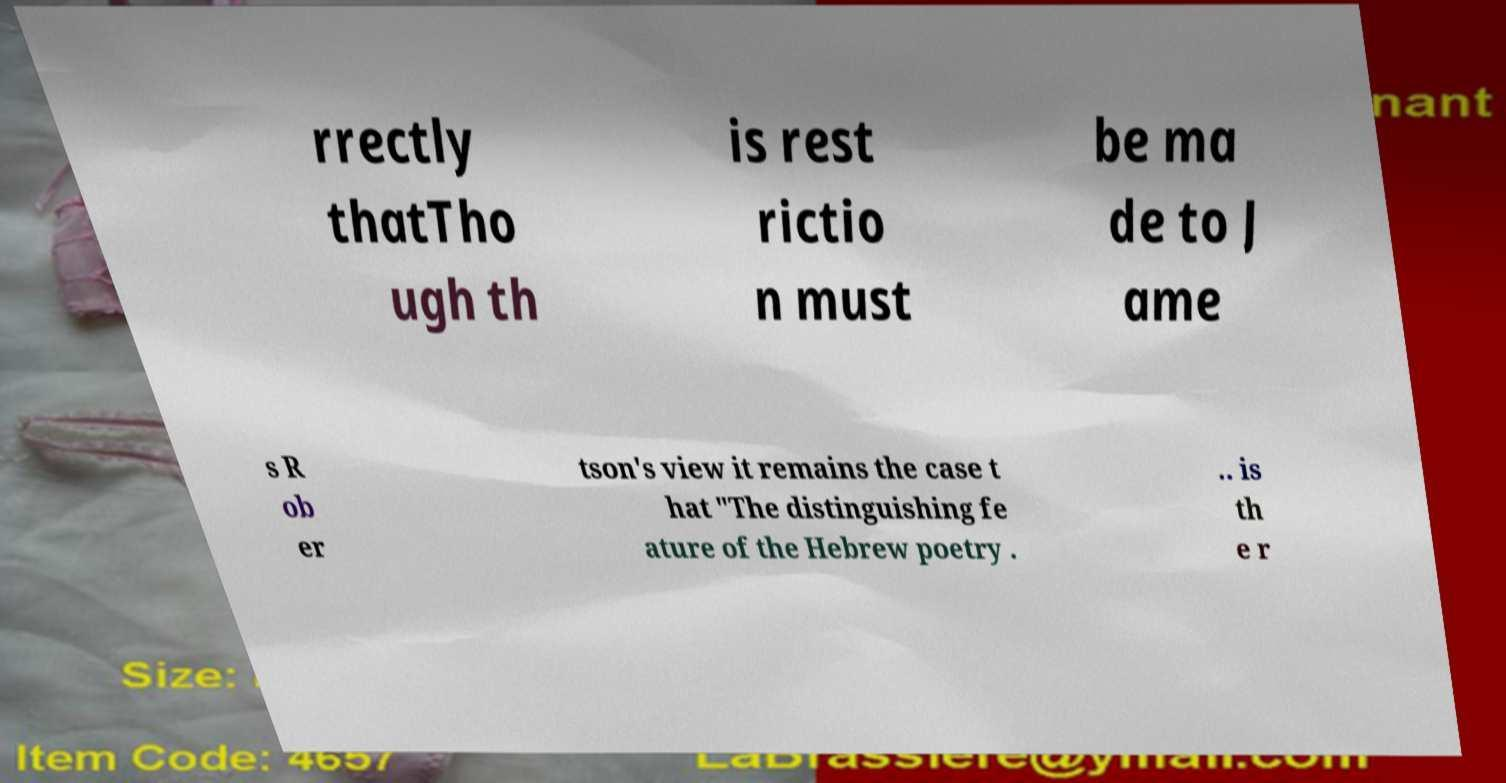For documentation purposes, I need the text within this image transcribed. Could you provide that? rrectly thatTho ugh th is rest rictio n must be ma de to J ame s R ob er tson's view it remains the case t hat "The distinguishing fe ature of the Hebrew poetry . .. is th e r 